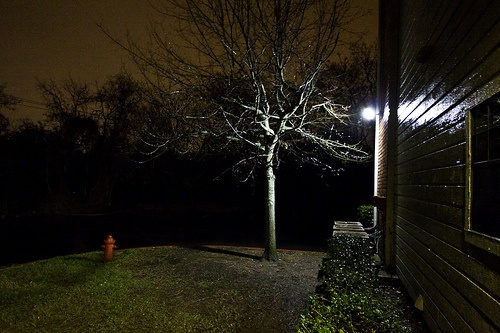Describe the objects in this image and their specific colors. I can see a fire hydrant in black, maroon, and brown tones in this image. 